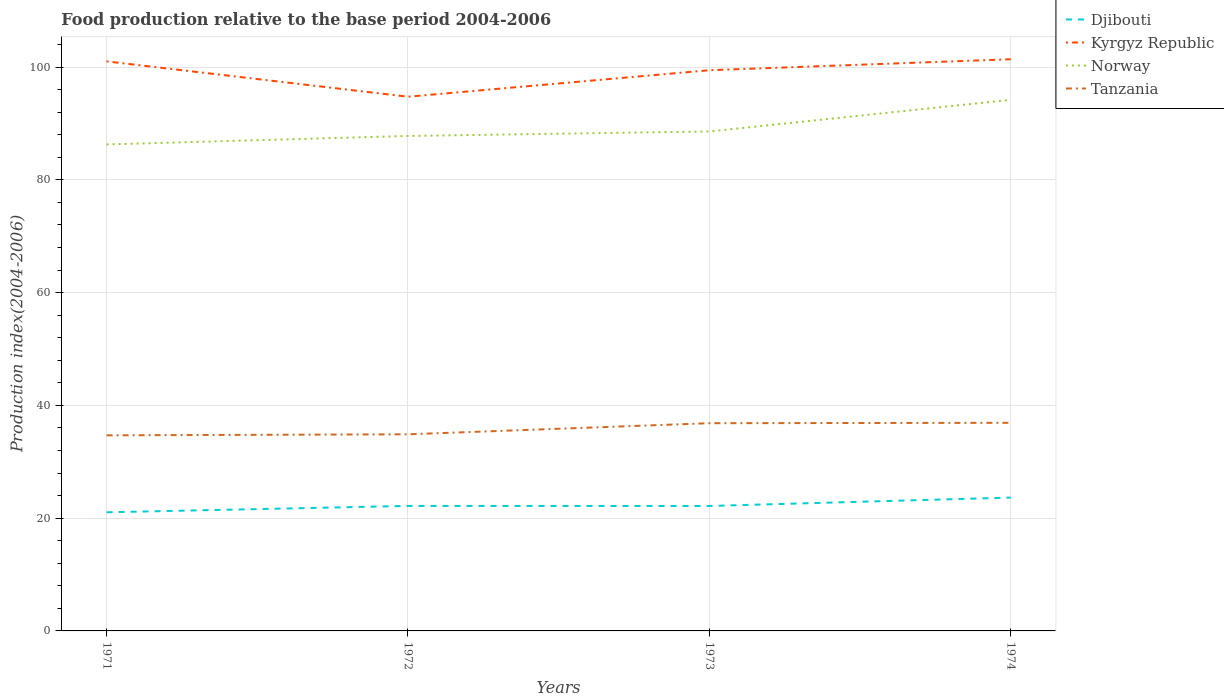Is the number of lines equal to the number of legend labels?
Your answer should be compact. Yes. Across all years, what is the maximum food production index in Kyrgyz Republic?
Provide a succinct answer. 94.74. What is the total food production index in Norway in the graph?
Provide a short and direct response. -7.91. What is the difference between the highest and the second highest food production index in Kyrgyz Republic?
Make the answer very short. 6.65. What is the difference between the highest and the lowest food production index in Djibouti?
Ensure brevity in your answer.  1. Is the food production index in Kyrgyz Republic strictly greater than the food production index in Norway over the years?
Give a very brief answer. No. How many years are there in the graph?
Offer a very short reply. 4. What is the difference between two consecutive major ticks on the Y-axis?
Give a very brief answer. 20. Are the values on the major ticks of Y-axis written in scientific E-notation?
Provide a succinct answer. No. Where does the legend appear in the graph?
Keep it short and to the point. Top right. What is the title of the graph?
Ensure brevity in your answer.  Food production relative to the base period 2004-2006. What is the label or title of the Y-axis?
Offer a very short reply. Production index(2004-2006). What is the Production index(2004-2006) of Djibouti in 1971?
Provide a short and direct response. 21.04. What is the Production index(2004-2006) in Kyrgyz Republic in 1971?
Ensure brevity in your answer.  101.01. What is the Production index(2004-2006) of Norway in 1971?
Offer a very short reply. 86.28. What is the Production index(2004-2006) in Tanzania in 1971?
Give a very brief answer. 34.69. What is the Production index(2004-2006) of Djibouti in 1972?
Your answer should be very brief. 22.17. What is the Production index(2004-2006) in Kyrgyz Republic in 1972?
Your answer should be compact. 94.74. What is the Production index(2004-2006) in Norway in 1972?
Ensure brevity in your answer.  87.78. What is the Production index(2004-2006) of Tanzania in 1972?
Keep it short and to the point. 34.87. What is the Production index(2004-2006) in Djibouti in 1973?
Provide a short and direct response. 22.16. What is the Production index(2004-2006) in Kyrgyz Republic in 1973?
Make the answer very short. 99.44. What is the Production index(2004-2006) in Norway in 1973?
Provide a short and direct response. 88.58. What is the Production index(2004-2006) of Tanzania in 1973?
Give a very brief answer. 36.84. What is the Production index(2004-2006) of Djibouti in 1974?
Give a very brief answer. 23.65. What is the Production index(2004-2006) in Kyrgyz Republic in 1974?
Offer a terse response. 101.39. What is the Production index(2004-2006) in Norway in 1974?
Provide a short and direct response. 94.19. What is the Production index(2004-2006) in Tanzania in 1974?
Offer a very short reply. 36.91. Across all years, what is the maximum Production index(2004-2006) of Djibouti?
Your answer should be compact. 23.65. Across all years, what is the maximum Production index(2004-2006) in Kyrgyz Republic?
Provide a succinct answer. 101.39. Across all years, what is the maximum Production index(2004-2006) of Norway?
Give a very brief answer. 94.19. Across all years, what is the maximum Production index(2004-2006) in Tanzania?
Your response must be concise. 36.91. Across all years, what is the minimum Production index(2004-2006) in Djibouti?
Keep it short and to the point. 21.04. Across all years, what is the minimum Production index(2004-2006) of Kyrgyz Republic?
Your answer should be very brief. 94.74. Across all years, what is the minimum Production index(2004-2006) in Norway?
Offer a very short reply. 86.28. Across all years, what is the minimum Production index(2004-2006) in Tanzania?
Keep it short and to the point. 34.69. What is the total Production index(2004-2006) in Djibouti in the graph?
Your response must be concise. 89.02. What is the total Production index(2004-2006) in Kyrgyz Republic in the graph?
Give a very brief answer. 396.58. What is the total Production index(2004-2006) of Norway in the graph?
Make the answer very short. 356.83. What is the total Production index(2004-2006) of Tanzania in the graph?
Give a very brief answer. 143.31. What is the difference between the Production index(2004-2006) in Djibouti in 1971 and that in 1972?
Your answer should be very brief. -1.13. What is the difference between the Production index(2004-2006) of Kyrgyz Republic in 1971 and that in 1972?
Your response must be concise. 6.27. What is the difference between the Production index(2004-2006) of Norway in 1971 and that in 1972?
Offer a very short reply. -1.5. What is the difference between the Production index(2004-2006) of Tanzania in 1971 and that in 1972?
Keep it short and to the point. -0.18. What is the difference between the Production index(2004-2006) in Djibouti in 1971 and that in 1973?
Provide a short and direct response. -1.12. What is the difference between the Production index(2004-2006) in Kyrgyz Republic in 1971 and that in 1973?
Offer a very short reply. 1.57. What is the difference between the Production index(2004-2006) in Tanzania in 1971 and that in 1973?
Offer a terse response. -2.15. What is the difference between the Production index(2004-2006) of Djibouti in 1971 and that in 1974?
Your response must be concise. -2.61. What is the difference between the Production index(2004-2006) in Kyrgyz Republic in 1971 and that in 1974?
Your answer should be very brief. -0.38. What is the difference between the Production index(2004-2006) in Norway in 1971 and that in 1974?
Give a very brief answer. -7.91. What is the difference between the Production index(2004-2006) in Tanzania in 1971 and that in 1974?
Keep it short and to the point. -2.22. What is the difference between the Production index(2004-2006) of Djibouti in 1972 and that in 1973?
Your answer should be compact. 0.01. What is the difference between the Production index(2004-2006) in Kyrgyz Republic in 1972 and that in 1973?
Offer a very short reply. -4.7. What is the difference between the Production index(2004-2006) in Norway in 1972 and that in 1973?
Your answer should be very brief. -0.8. What is the difference between the Production index(2004-2006) in Tanzania in 1972 and that in 1973?
Keep it short and to the point. -1.97. What is the difference between the Production index(2004-2006) in Djibouti in 1972 and that in 1974?
Provide a succinct answer. -1.48. What is the difference between the Production index(2004-2006) in Kyrgyz Republic in 1972 and that in 1974?
Your answer should be compact. -6.65. What is the difference between the Production index(2004-2006) of Norway in 1972 and that in 1974?
Your answer should be compact. -6.41. What is the difference between the Production index(2004-2006) of Tanzania in 1972 and that in 1974?
Your response must be concise. -2.04. What is the difference between the Production index(2004-2006) of Djibouti in 1973 and that in 1974?
Your answer should be very brief. -1.49. What is the difference between the Production index(2004-2006) in Kyrgyz Republic in 1973 and that in 1974?
Your response must be concise. -1.95. What is the difference between the Production index(2004-2006) in Norway in 1973 and that in 1974?
Your response must be concise. -5.61. What is the difference between the Production index(2004-2006) in Tanzania in 1973 and that in 1974?
Your answer should be very brief. -0.07. What is the difference between the Production index(2004-2006) of Djibouti in 1971 and the Production index(2004-2006) of Kyrgyz Republic in 1972?
Provide a succinct answer. -73.7. What is the difference between the Production index(2004-2006) of Djibouti in 1971 and the Production index(2004-2006) of Norway in 1972?
Ensure brevity in your answer.  -66.74. What is the difference between the Production index(2004-2006) in Djibouti in 1971 and the Production index(2004-2006) in Tanzania in 1972?
Provide a short and direct response. -13.83. What is the difference between the Production index(2004-2006) of Kyrgyz Republic in 1971 and the Production index(2004-2006) of Norway in 1972?
Give a very brief answer. 13.23. What is the difference between the Production index(2004-2006) in Kyrgyz Republic in 1971 and the Production index(2004-2006) in Tanzania in 1972?
Your answer should be compact. 66.14. What is the difference between the Production index(2004-2006) of Norway in 1971 and the Production index(2004-2006) of Tanzania in 1972?
Your answer should be very brief. 51.41. What is the difference between the Production index(2004-2006) of Djibouti in 1971 and the Production index(2004-2006) of Kyrgyz Republic in 1973?
Your response must be concise. -78.4. What is the difference between the Production index(2004-2006) of Djibouti in 1971 and the Production index(2004-2006) of Norway in 1973?
Offer a terse response. -67.54. What is the difference between the Production index(2004-2006) of Djibouti in 1971 and the Production index(2004-2006) of Tanzania in 1973?
Provide a succinct answer. -15.8. What is the difference between the Production index(2004-2006) in Kyrgyz Republic in 1971 and the Production index(2004-2006) in Norway in 1973?
Give a very brief answer. 12.43. What is the difference between the Production index(2004-2006) of Kyrgyz Republic in 1971 and the Production index(2004-2006) of Tanzania in 1973?
Make the answer very short. 64.17. What is the difference between the Production index(2004-2006) in Norway in 1971 and the Production index(2004-2006) in Tanzania in 1973?
Provide a short and direct response. 49.44. What is the difference between the Production index(2004-2006) in Djibouti in 1971 and the Production index(2004-2006) in Kyrgyz Republic in 1974?
Ensure brevity in your answer.  -80.35. What is the difference between the Production index(2004-2006) of Djibouti in 1971 and the Production index(2004-2006) of Norway in 1974?
Ensure brevity in your answer.  -73.15. What is the difference between the Production index(2004-2006) in Djibouti in 1971 and the Production index(2004-2006) in Tanzania in 1974?
Keep it short and to the point. -15.87. What is the difference between the Production index(2004-2006) of Kyrgyz Republic in 1971 and the Production index(2004-2006) of Norway in 1974?
Provide a short and direct response. 6.82. What is the difference between the Production index(2004-2006) in Kyrgyz Republic in 1971 and the Production index(2004-2006) in Tanzania in 1974?
Provide a succinct answer. 64.1. What is the difference between the Production index(2004-2006) of Norway in 1971 and the Production index(2004-2006) of Tanzania in 1974?
Ensure brevity in your answer.  49.37. What is the difference between the Production index(2004-2006) of Djibouti in 1972 and the Production index(2004-2006) of Kyrgyz Republic in 1973?
Give a very brief answer. -77.27. What is the difference between the Production index(2004-2006) of Djibouti in 1972 and the Production index(2004-2006) of Norway in 1973?
Your response must be concise. -66.41. What is the difference between the Production index(2004-2006) in Djibouti in 1972 and the Production index(2004-2006) in Tanzania in 1973?
Keep it short and to the point. -14.67. What is the difference between the Production index(2004-2006) of Kyrgyz Republic in 1972 and the Production index(2004-2006) of Norway in 1973?
Provide a succinct answer. 6.16. What is the difference between the Production index(2004-2006) in Kyrgyz Republic in 1972 and the Production index(2004-2006) in Tanzania in 1973?
Provide a short and direct response. 57.9. What is the difference between the Production index(2004-2006) of Norway in 1972 and the Production index(2004-2006) of Tanzania in 1973?
Give a very brief answer. 50.94. What is the difference between the Production index(2004-2006) of Djibouti in 1972 and the Production index(2004-2006) of Kyrgyz Republic in 1974?
Your answer should be compact. -79.22. What is the difference between the Production index(2004-2006) in Djibouti in 1972 and the Production index(2004-2006) in Norway in 1974?
Provide a succinct answer. -72.02. What is the difference between the Production index(2004-2006) of Djibouti in 1972 and the Production index(2004-2006) of Tanzania in 1974?
Provide a short and direct response. -14.74. What is the difference between the Production index(2004-2006) in Kyrgyz Republic in 1972 and the Production index(2004-2006) in Norway in 1974?
Offer a terse response. 0.55. What is the difference between the Production index(2004-2006) in Kyrgyz Republic in 1972 and the Production index(2004-2006) in Tanzania in 1974?
Offer a very short reply. 57.83. What is the difference between the Production index(2004-2006) of Norway in 1972 and the Production index(2004-2006) of Tanzania in 1974?
Your response must be concise. 50.87. What is the difference between the Production index(2004-2006) of Djibouti in 1973 and the Production index(2004-2006) of Kyrgyz Republic in 1974?
Give a very brief answer. -79.23. What is the difference between the Production index(2004-2006) of Djibouti in 1973 and the Production index(2004-2006) of Norway in 1974?
Ensure brevity in your answer.  -72.03. What is the difference between the Production index(2004-2006) in Djibouti in 1973 and the Production index(2004-2006) in Tanzania in 1974?
Offer a terse response. -14.75. What is the difference between the Production index(2004-2006) of Kyrgyz Republic in 1973 and the Production index(2004-2006) of Norway in 1974?
Your answer should be compact. 5.25. What is the difference between the Production index(2004-2006) in Kyrgyz Republic in 1973 and the Production index(2004-2006) in Tanzania in 1974?
Offer a terse response. 62.53. What is the difference between the Production index(2004-2006) in Norway in 1973 and the Production index(2004-2006) in Tanzania in 1974?
Make the answer very short. 51.67. What is the average Production index(2004-2006) of Djibouti per year?
Offer a very short reply. 22.25. What is the average Production index(2004-2006) in Kyrgyz Republic per year?
Offer a terse response. 99.14. What is the average Production index(2004-2006) of Norway per year?
Offer a very short reply. 89.21. What is the average Production index(2004-2006) in Tanzania per year?
Keep it short and to the point. 35.83. In the year 1971, what is the difference between the Production index(2004-2006) of Djibouti and Production index(2004-2006) of Kyrgyz Republic?
Keep it short and to the point. -79.97. In the year 1971, what is the difference between the Production index(2004-2006) in Djibouti and Production index(2004-2006) in Norway?
Give a very brief answer. -65.24. In the year 1971, what is the difference between the Production index(2004-2006) in Djibouti and Production index(2004-2006) in Tanzania?
Your response must be concise. -13.65. In the year 1971, what is the difference between the Production index(2004-2006) in Kyrgyz Republic and Production index(2004-2006) in Norway?
Offer a very short reply. 14.73. In the year 1971, what is the difference between the Production index(2004-2006) in Kyrgyz Republic and Production index(2004-2006) in Tanzania?
Give a very brief answer. 66.32. In the year 1971, what is the difference between the Production index(2004-2006) in Norway and Production index(2004-2006) in Tanzania?
Give a very brief answer. 51.59. In the year 1972, what is the difference between the Production index(2004-2006) in Djibouti and Production index(2004-2006) in Kyrgyz Republic?
Your answer should be compact. -72.57. In the year 1972, what is the difference between the Production index(2004-2006) of Djibouti and Production index(2004-2006) of Norway?
Your answer should be very brief. -65.61. In the year 1972, what is the difference between the Production index(2004-2006) in Kyrgyz Republic and Production index(2004-2006) in Norway?
Offer a very short reply. 6.96. In the year 1972, what is the difference between the Production index(2004-2006) of Kyrgyz Republic and Production index(2004-2006) of Tanzania?
Ensure brevity in your answer.  59.87. In the year 1972, what is the difference between the Production index(2004-2006) of Norway and Production index(2004-2006) of Tanzania?
Offer a very short reply. 52.91. In the year 1973, what is the difference between the Production index(2004-2006) in Djibouti and Production index(2004-2006) in Kyrgyz Republic?
Ensure brevity in your answer.  -77.28. In the year 1973, what is the difference between the Production index(2004-2006) in Djibouti and Production index(2004-2006) in Norway?
Give a very brief answer. -66.42. In the year 1973, what is the difference between the Production index(2004-2006) of Djibouti and Production index(2004-2006) of Tanzania?
Provide a short and direct response. -14.68. In the year 1973, what is the difference between the Production index(2004-2006) in Kyrgyz Republic and Production index(2004-2006) in Norway?
Your response must be concise. 10.86. In the year 1973, what is the difference between the Production index(2004-2006) of Kyrgyz Republic and Production index(2004-2006) of Tanzania?
Keep it short and to the point. 62.6. In the year 1973, what is the difference between the Production index(2004-2006) in Norway and Production index(2004-2006) in Tanzania?
Your answer should be compact. 51.74. In the year 1974, what is the difference between the Production index(2004-2006) of Djibouti and Production index(2004-2006) of Kyrgyz Republic?
Keep it short and to the point. -77.74. In the year 1974, what is the difference between the Production index(2004-2006) in Djibouti and Production index(2004-2006) in Norway?
Provide a short and direct response. -70.54. In the year 1974, what is the difference between the Production index(2004-2006) in Djibouti and Production index(2004-2006) in Tanzania?
Your answer should be compact. -13.26. In the year 1974, what is the difference between the Production index(2004-2006) of Kyrgyz Republic and Production index(2004-2006) of Norway?
Provide a succinct answer. 7.2. In the year 1974, what is the difference between the Production index(2004-2006) of Kyrgyz Republic and Production index(2004-2006) of Tanzania?
Offer a terse response. 64.48. In the year 1974, what is the difference between the Production index(2004-2006) in Norway and Production index(2004-2006) in Tanzania?
Provide a short and direct response. 57.28. What is the ratio of the Production index(2004-2006) in Djibouti in 1971 to that in 1972?
Your answer should be very brief. 0.95. What is the ratio of the Production index(2004-2006) in Kyrgyz Republic in 1971 to that in 1972?
Your response must be concise. 1.07. What is the ratio of the Production index(2004-2006) in Norway in 1971 to that in 1972?
Give a very brief answer. 0.98. What is the ratio of the Production index(2004-2006) of Djibouti in 1971 to that in 1973?
Your answer should be compact. 0.95. What is the ratio of the Production index(2004-2006) in Kyrgyz Republic in 1971 to that in 1973?
Make the answer very short. 1.02. What is the ratio of the Production index(2004-2006) in Tanzania in 1971 to that in 1973?
Keep it short and to the point. 0.94. What is the ratio of the Production index(2004-2006) of Djibouti in 1971 to that in 1974?
Make the answer very short. 0.89. What is the ratio of the Production index(2004-2006) of Kyrgyz Republic in 1971 to that in 1974?
Your answer should be very brief. 1. What is the ratio of the Production index(2004-2006) in Norway in 1971 to that in 1974?
Offer a very short reply. 0.92. What is the ratio of the Production index(2004-2006) of Tanzania in 1971 to that in 1974?
Your answer should be compact. 0.94. What is the ratio of the Production index(2004-2006) of Djibouti in 1972 to that in 1973?
Ensure brevity in your answer.  1. What is the ratio of the Production index(2004-2006) in Kyrgyz Republic in 1972 to that in 1973?
Give a very brief answer. 0.95. What is the ratio of the Production index(2004-2006) in Norway in 1972 to that in 1973?
Give a very brief answer. 0.99. What is the ratio of the Production index(2004-2006) in Tanzania in 1972 to that in 1973?
Your answer should be very brief. 0.95. What is the ratio of the Production index(2004-2006) of Djibouti in 1972 to that in 1974?
Provide a short and direct response. 0.94. What is the ratio of the Production index(2004-2006) of Kyrgyz Republic in 1972 to that in 1974?
Give a very brief answer. 0.93. What is the ratio of the Production index(2004-2006) of Norway in 1972 to that in 1974?
Ensure brevity in your answer.  0.93. What is the ratio of the Production index(2004-2006) in Tanzania in 1972 to that in 1974?
Your answer should be compact. 0.94. What is the ratio of the Production index(2004-2006) in Djibouti in 1973 to that in 1974?
Your response must be concise. 0.94. What is the ratio of the Production index(2004-2006) of Kyrgyz Republic in 1973 to that in 1974?
Make the answer very short. 0.98. What is the ratio of the Production index(2004-2006) in Norway in 1973 to that in 1974?
Keep it short and to the point. 0.94. What is the ratio of the Production index(2004-2006) of Tanzania in 1973 to that in 1974?
Provide a short and direct response. 1. What is the difference between the highest and the second highest Production index(2004-2006) of Djibouti?
Offer a terse response. 1.48. What is the difference between the highest and the second highest Production index(2004-2006) of Kyrgyz Republic?
Offer a very short reply. 0.38. What is the difference between the highest and the second highest Production index(2004-2006) in Norway?
Your response must be concise. 5.61. What is the difference between the highest and the second highest Production index(2004-2006) of Tanzania?
Your response must be concise. 0.07. What is the difference between the highest and the lowest Production index(2004-2006) of Djibouti?
Offer a terse response. 2.61. What is the difference between the highest and the lowest Production index(2004-2006) in Kyrgyz Republic?
Keep it short and to the point. 6.65. What is the difference between the highest and the lowest Production index(2004-2006) in Norway?
Ensure brevity in your answer.  7.91. What is the difference between the highest and the lowest Production index(2004-2006) of Tanzania?
Your response must be concise. 2.22. 